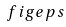<formula> <loc_0><loc_0><loc_500><loc_500>\ f i g { e p s }</formula> 